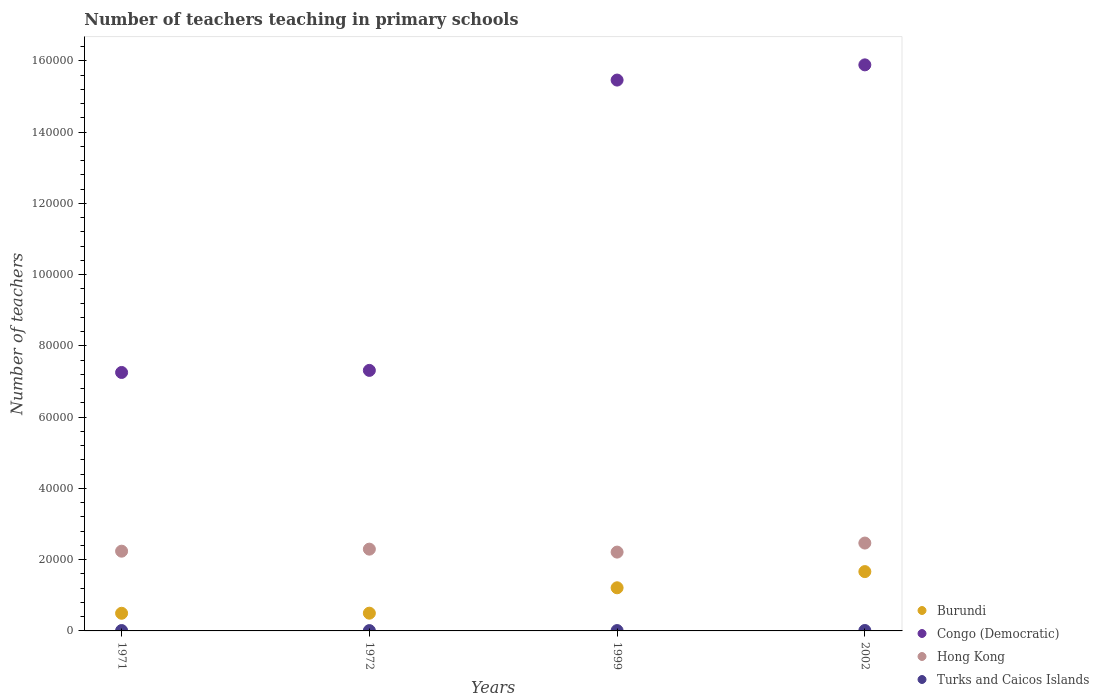What is the number of teachers teaching in primary schools in Hong Kong in 1999?
Your response must be concise. 2.21e+04. Across all years, what is the maximum number of teachers teaching in primary schools in Hong Kong?
Offer a terse response. 2.47e+04. Across all years, what is the minimum number of teachers teaching in primary schools in Turks and Caicos Islands?
Your answer should be very brief. 90. In which year was the number of teachers teaching in primary schools in Congo (Democratic) maximum?
Your answer should be compact. 2002. What is the total number of teachers teaching in primary schools in Congo (Democratic) in the graph?
Your answer should be compact. 4.59e+05. What is the difference between the number of teachers teaching in primary schools in Congo (Democratic) in 1971 and that in 1999?
Your answer should be compact. -8.21e+04. What is the difference between the number of teachers teaching in primary schools in Burundi in 1971 and the number of teachers teaching in primary schools in Turks and Caicos Islands in 1999?
Your answer should be compact. 4856. What is the average number of teachers teaching in primary schools in Hong Kong per year?
Your answer should be very brief. 2.30e+04. In the year 1999, what is the difference between the number of teachers teaching in primary schools in Congo (Democratic) and number of teachers teaching in primary schools in Burundi?
Offer a terse response. 1.43e+05. What is the ratio of the number of teachers teaching in primary schools in Burundi in 1971 to that in 2002?
Offer a very short reply. 0.3. Is the difference between the number of teachers teaching in primary schools in Congo (Democratic) in 1971 and 1972 greater than the difference between the number of teachers teaching in primary schools in Burundi in 1971 and 1972?
Make the answer very short. No. What is the difference between the highest and the second highest number of teachers teaching in primary schools in Congo (Democratic)?
Your answer should be compact. 4269. What is the difference between the highest and the lowest number of teachers teaching in primary schools in Hong Kong?
Your response must be concise. 2540. In how many years, is the number of teachers teaching in primary schools in Burundi greater than the average number of teachers teaching in primary schools in Burundi taken over all years?
Ensure brevity in your answer.  2. Is it the case that in every year, the sum of the number of teachers teaching in primary schools in Burundi and number of teachers teaching in primary schools in Turks and Caicos Islands  is greater than the sum of number of teachers teaching in primary schools in Hong Kong and number of teachers teaching in primary schools in Congo (Democratic)?
Provide a succinct answer. No. Is it the case that in every year, the sum of the number of teachers teaching in primary schools in Hong Kong and number of teachers teaching in primary schools in Congo (Democratic)  is greater than the number of teachers teaching in primary schools in Burundi?
Make the answer very short. Yes. Is the number of teachers teaching in primary schools in Congo (Democratic) strictly less than the number of teachers teaching in primary schools in Turks and Caicos Islands over the years?
Keep it short and to the point. No. How many years are there in the graph?
Provide a short and direct response. 4. What is the difference between two consecutive major ticks on the Y-axis?
Ensure brevity in your answer.  2.00e+04. Are the values on the major ticks of Y-axis written in scientific E-notation?
Make the answer very short. No. Does the graph contain any zero values?
Make the answer very short. No. What is the title of the graph?
Ensure brevity in your answer.  Number of teachers teaching in primary schools. Does "High income: nonOECD" appear as one of the legend labels in the graph?
Ensure brevity in your answer.  No. What is the label or title of the X-axis?
Your answer should be very brief. Years. What is the label or title of the Y-axis?
Your answer should be very brief. Number of teachers. What is the Number of teachers of Burundi in 1971?
Give a very brief answer. 4955. What is the Number of teachers of Congo (Democratic) in 1971?
Ensure brevity in your answer.  7.25e+04. What is the Number of teachers in Hong Kong in 1971?
Your answer should be compact. 2.24e+04. What is the Number of teachers in Turks and Caicos Islands in 1971?
Keep it short and to the point. 106. What is the Number of teachers of Burundi in 1972?
Your response must be concise. 4980. What is the Number of teachers in Congo (Democratic) in 1972?
Keep it short and to the point. 7.31e+04. What is the Number of teachers of Hong Kong in 1972?
Your answer should be compact. 2.30e+04. What is the Number of teachers of Burundi in 1999?
Ensure brevity in your answer.  1.21e+04. What is the Number of teachers of Congo (Democratic) in 1999?
Your answer should be compact. 1.55e+05. What is the Number of teachers of Hong Kong in 1999?
Give a very brief answer. 2.21e+04. What is the Number of teachers in Turks and Caicos Islands in 1999?
Make the answer very short. 99. What is the Number of teachers of Burundi in 2002?
Offer a very short reply. 1.67e+04. What is the Number of teachers of Congo (Democratic) in 2002?
Ensure brevity in your answer.  1.59e+05. What is the Number of teachers in Hong Kong in 2002?
Your response must be concise. 2.47e+04. What is the Number of teachers in Turks and Caicos Islands in 2002?
Make the answer very short. 119. Across all years, what is the maximum Number of teachers of Burundi?
Ensure brevity in your answer.  1.67e+04. Across all years, what is the maximum Number of teachers of Congo (Democratic)?
Offer a very short reply. 1.59e+05. Across all years, what is the maximum Number of teachers of Hong Kong?
Provide a succinct answer. 2.47e+04. Across all years, what is the maximum Number of teachers of Turks and Caicos Islands?
Your response must be concise. 119. Across all years, what is the minimum Number of teachers of Burundi?
Provide a succinct answer. 4955. Across all years, what is the minimum Number of teachers in Congo (Democratic)?
Offer a terse response. 7.25e+04. Across all years, what is the minimum Number of teachers in Hong Kong?
Offer a terse response. 2.21e+04. What is the total Number of teachers in Burundi in the graph?
Your response must be concise. 3.87e+04. What is the total Number of teachers in Congo (Democratic) in the graph?
Make the answer very short. 4.59e+05. What is the total Number of teachers in Hong Kong in the graph?
Your answer should be very brief. 9.21e+04. What is the total Number of teachers of Turks and Caicos Islands in the graph?
Your answer should be compact. 414. What is the difference between the Number of teachers in Burundi in 1971 and that in 1972?
Your answer should be very brief. -25. What is the difference between the Number of teachers of Congo (Democratic) in 1971 and that in 1972?
Your answer should be very brief. -583. What is the difference between the Number of teachers of Hong Kong in 1971 and that in 1972?
Your answer should be very brief. -570. What is the difference between the Number of teachers of Turks and Caicos Islands in 1971 and that in 1972?
Ensure brevity in your answer.  16. What is the difference between the Number of teachers in Burundi in 1971 and that in 1999?
Keep it short and to the point. -7152. What is the difference between the Number of teachers in Congo (Democratic) in 1971 and that in 1999?
Your response must be concise. -8.21e+04. What is the difference between the Number of teachers in Hong Kong in 1971 and that in 1999?
Give a very brief answer. 260. What is the difference between the Number of teachers of Turks and Caicos Islands in 1971 and that in 1999?
Offer a very short reply. 7. What is the difference between the Number of teachers of Burundi in 1971 and that in 2002?
Your answer should be compact. -1.17e+04. What is the difference between the Number of teachers of Congo (Democratic) in 1971 and that in 2002?
Your answer should be very brief. -8.63e+04. What is the difference between the Number of teachers of Hong Kong in 1971 and that in 2002?
Offer a terse response. -2280. What is the difference between the Number of teachers of Turks and Caicos Islands in 1971 and that in 2002?
Provide a succinct answer. -13. What is the difference between the Number of teachers in Burundi in 1972 and that in 1999?
Ensure brevity in your answer.  -7127. What is the difference between the Number of teachers of Congo (Democratic) in 1972 and that in 1999?
Your answer should be compact. -8.15e+04. What is the difference between the Number of teachers in Hong Kong in 1972 and that in 1999?
Make the answer very short. 830. What is the difference between the Number of teachers in Burundi in 1972 and that in 2002?
Give a very brief answer. -1.17e+04. What is the difference between the Number of teachers of Congo (Democratic) in 1972 and that in 2002?
Ensure brevity in your answer.  -8.58e+04. What is the difference between the Number of teachers in Hong Kong in 1972 and that in 2002?
Offer a very short reply. -1710. What is the difference between the Number of teachers in Burundi in 1999 and that in 2002?
Your answer should be very brief. -4544. What is the difference between the Number of teachers of Congo (Democratic) in 1999 and that in 2002?
Provide a short and direct response. -4269. What is the difference between the Number of teachers of Hong Kong in 1999 and that in 2002?
Make the answer very short. -2540. What is the difference between the Number of teachers in Turks and Caicos Islands in 1999 and that in 2002?
Make the answer very short. -20. What is the difference between the Number of teachers in Burundi in 1971 and the Number of teachers in Congo (Democratic) in 1972?
Offer a terse response. -6.82e+04. What is the difference between the Number of teachers in Burundi in 1971 and the Number of teachers in Hong Kong in 1972?
Offer a terse response. -1.80e+04. What is the difference between the Number of teachers in Burundi in 1971 and the Number of teachers in Turks and Caicos Islands in 1972?
Provide a short and direct response. 4865. What is the difference between the Number of teachers of Congo (Democratic) in 1971 and the Number of teachers of Hong Kong in 1972?
Offer a terse response. 4.96e+04. What is the difference between the Number of teachers of Congo (Democratic) in 1971 and the Number of teachers of Turks and Caicos Islands in 1972?
Keep it short and to the point. 7.25e+04. What is the difference between the Number of teachers in Hong Kong in 1971 and the Number of teachers in Turks and Caicos Islands in 1972?
Ensure brevity in your answer.  2.23e+04. What is the difference between the Number of teachers in Burundi in 1971 and the Number of teachers in Congo (Democratic) in 1999?
Keep it short and to the point. -1.50e+05. What is the difference between the Number of teachers of Burundi in 1971 and the Number of teachers of Hong Kong in 1999?
Your answer should be compact. -1.72e+04. What is the difference between the Number of teachers of Burundi in 1971 and the Number of teachers of Turks and Caicos Islands in 1999?
Your answer should be very brief. 4856. What is the difference between the Number of teachers of Congo (Democratic) in 1971 and the Number of teachers of Hong Kong in 1999?
Ensure brevity in your answer.  5.04e+04. What is the difference between the Number of teachers in Congo (Democratic) in 1971 and the Number of teachers in Turks and Caicos Islands in 1999?
Keep it short and to the point. 7.24e+04. What is the difference between the Number of teachers in Hong Kong in 1971 and the Number of teachers in Turks and Caicos Islands in 1999?
Your response must be concise. 2.23e+04. What is the difference between the Number of teachers of Burundi in 1971 and the Number of teachers of Congo (Democratic) in 2002?
Keep it short and to the point. -1.54e+05. What is the difference between the Number of teachers of Burundi in 1971 and the Number of teachers of Hong Kong in 2002?
Your answer should be compact. -1.97e+04. What is the difference between the Number of teachers in Burundi in 1971 and the Number of teachers in Turks and Caicos Islands in 2002?
Your answer should be very brief. 4836. What is the difference between the Number of teachers in Congo (Democratic) in 1971 and the Number of teachers in Hong Kong in 2002?
Give a very brief answer. 4.79e+04. What is the difference between the Number of teachers of Congo (Democratic) in 1971 and the Number of teachers of Turks and Caicos Islands in 2002?
Give a very brief answer. 7.24e+04. What is the difference between the Number of teachers in Hong Kong in 1971 and the Number of teachers in Turks and Caicos Islands in 2002?
Make the answer very short. 2.23e+04. What is the difference between the Number of teachers of Burundi in 1972 and the Number of teachers of Congo (Democratic) in 1999?
Give a very brief answer. -1.50e+05. What is the difference between the Number of teachers of Burundi in 1972 and the Number of teachers of Hong Kong in 1999?
Give a very brief answer. -1.71e+04. What is the difference between the Number of teachers of Burundi in 1972 and the Number of teachers of Turks and Caicos Islands in 1999?
Make the answer very short. 4881. What is the difference between the Number of teachers in Congo (Democratic) in 1972 and the Number of teachers in Hong Kong in 1999?
Keep it short and to the point. 5.10e+04. What is the difference between the Number of teachers of Congo (Democratic) in 1972 and the Number of teachers of Turks and Caicos Islands in 1999?
Provide a short and direct response. 7.30e+04. What is the difference between the Number of teachers of Hong Kong in 1972 and the Number of teachers of Turks and Caicos Islands in 1999?
Provide a short and direct response. 2.29e+04. What is the difference between the Number of teachers in Burundi in 1972 and the Number of teachers in Congo (Democratic) in 2002?
Keep it short and to the point. -1.54e+05. What is the difference between the Number of teachers in Burundi in 1972 and the Number of teachers in Hong Kong in 2002?
Provide a succinct answer. -1.97e+04. What is the difference between the Number of teachers in Burundi in 1972 and the Number of teachers in Turks and Caicos Islands in 2002?
Your answer should be very brief. 4861. What is the difference between the Number of teachers in Congo (Democratic) in 1972 and the Number of teachers in Hong Kong in 2002?
Keep it short and to the point. 4.85e+04. What is the difference between the Number of teachers in Congo (Democratic) in 1972 and the Number of teachers in Turks and Caicos Islands in 2002?
Your response must be concise. 7.30e+04. What is the difference between the Number of teachers in Hong Kong in 1972 and the Number of teachers in Turks and Caicos Islands in 2002?
Make the answer very short. 2.28e+04. What is the difference between the Number of teachers in Burundi in 1999 and the Number of teachers in Congo (Democratic) in 2002?
Your response must be concise. -1.47e+05. What is the difference between the Number of teachers of Burundi in 1999 and the Number of teachers of Hong Kong in 2002?
Make the answer very short. -1.26e+04. What is the difference between the Number of teachers of Burundi in 1999 and the Number of teachers of Turks and Caicos Islands in 2002?
Offer a very short reply. 1.20e+04. What is the difference between the Number of teachers in Congo (Democratic) in 1999 and the Number of teachers in Hong Kong in 2002?
Offer a very short reply. 1.30e+05. What is the difference between the Number of teachers of Congo (Democratic) in 1999 and the Number of teachers of Turks and Caicos Islands in 2002?
Ensure brevity in your answer.  1.54e+05. What is the difference between the Number of teachers of Hong Kong in 1999 and the Number of teachers of Turks and Caicos Islands in 2002?
Your answer should be very brief. 2.20e+04. What is the average Number of teachers of Burundi per year?
Make the answer very short. 9673.25. What is the average Number of teachers of Congo (Democratic) per year?
Provide a succinct answer. 1.15e+05. What is the average Number of teachers in Hong Kong per year?
Offer a terse response. 2.30e+04. What is the average Number of teachers of Turks and Caicos Islands per year?
Your answer should be compact. 103.5. In the year 1971, what is the difference between the Number of teachers in Burundi and Number of teachers in Congo (Democratic)?
Your answer should be compact. -6.76e+04. In the year 1971, what is the difference between the Number of teachers in Burundi and Number of teachers in Hong Kong?
Offer a very short reply. -1.74e+04. In the year 1971, what is the difference between the Number of teachers of Burundi and Number of teachers of Turks and Caicos Islands?
Make the answer very short. 4849. In the year 1971, what is the difference between the Number of teachers of Congo (Democratic) and Number of teachers of Hong Kong?
Your answer should be very brief. 5.02e+04. In the year 1971, what is the difference between the Number of teachers in Congo (Democratic) and Number of teachers in Turks and Caicos Islands?
Your response must be concise. 7.24e+04. In the year 1971, what is the difference between the Number of teachers of Hong Kong and Number of teachers of Turks and Caicos Islands?
Keep it short and to the point. 2.23e+04. In the year 1972, what is the difference between the Number of teachers in Burundi and Number of teachers in Congo (Democratic)?
Keep it short and to the point. -6.81e+04. In the year 1972, what is the difference between the Number of teachers of Burundi and Number of teachers of Hong Kong?
Provide a short and direct response. -1.80e+04. In the year 1972, what is the difference between the Number of teachers in Burundi and Number of teachers in Turks and Caicos Islands?
Keep it short and to the point. 4890. In the year 1972, what is the difference between the Number of teachers in Congo (Democratic) and Number of teachers in Hong Kong?
Ensure brevity in your answer.  5.02e+04. In the year 1972, what is the difference between the Number of teachers of Congo (Democratic) and Number of teachers of Turks and Caicos Islands?
Give a very brief answer. 7.30e+04. In the year 1972, what is the difference between the Number of teachers in Hong Kong and Number of teachers in Turks and Caicos Islands?
Provide a succinct answer. 2.29e+04. In the year 1999, what is the difference between the Number of teachers of Burundi and Number of teachers of Congo (Democratic)?
Offer a very short reply. -1.43e+05. In the year 1999, what is the difference between the Number of teachers of Burundi and Number of teachers of Hong Kong?
Keep it short and to the point. -1.00e+04. In the year 1999, what is the difference between the Number of teachers in Burundi and Number of teachers in Turks and Caicos Islands?
Offer a terse response. 1.20e+04. In the year 1999, what is the difference between the Number of teachers in Congo (Democratic) and Number of teachers in Hong Kong?
Keep it short and to the point. 1.32e+05. In the year 1999, what is the difference between the Number of teachers in Congo (Democratic) and Number of teachers in Turks and Caicos Islands?
Offer a terse response. 1.55e+05. In the year 1999, what is the difference between the Number of teachers of Hong Kong and Number of teachers of Turks and Caicos Islands?
Provide a succinct answer. 2.20e+04. In the year 2002, what is the difference between the Number of teachers of Burundi and Number of teachers of Congo (Democratic)?
Ensure brevity in your answer.  -1.42e+05. In the year 2002, what is the difference between the Number of teachers in Burundi and Number of teachers in Hong Kong?
Offer a terse response. -8012. In the year 2002, what is the difference between the Number of teachers of Burundi and Number of teachers of Turks and Caicos Islands?
Ensure brevity in your answer.  1.65e+04. In the year 2002, what is the difference between the Number of teachers in Congo (Democratic) and Number of teachers in Hong Kong?
Offer a terse response. 1.34e+05. In the year 2002, what is the difference between the Number of teachers of Congo (Democratic) and Number of teachers of Turks and Caicos Islands?
Your answer should be compact. 1.59e+05. In the year 2002, what is the difference between the Number of teachers in Hong Kong and Number of teachers in Turks and Caicos Islands?
Ensure brevity in your answer.  2.45e+04. What is the ratio of the Number of teachers of Hong Kong in 1971 to that in 1972?
Your response must be concise. 0.98. What is the ratio of the Number of teachers of Turks and Caicos Islands in 1971 to that in 1972?
Keep it short and to the point. 1.18. What is the ratio of the Number of teachers in Burundi in 1971 to that in 1999?
Provide a short and direct response. 0.41. What is the ratio of the Number of teachers of Congo (Democratic) in 1971 to that in 1999?
Provide a succinct answer. 0.47. What is the ratio of the Number of teachers in Hong Kong in 1971 to that in 1999?
Give a very brief answer. 1.01. What is the ratio of the Number of teachers of Turks and Caicos Islands in 1971 to that in 1999?
Give a very brief answer. 1.07. What is the ratio of the Number of teachers of Burundi in 1971 to that in 2002?
Keep it short and to the point. 0.3. What is the ratio of the Number of teachers in Congo (Democratic) in 1971 to that in 2002?
Your answer should be compact. 0.46. What is the ratio of the Number of teachers of Hong Kong in 1971 to that in 2002?
Your answer should be very brief. 0.91. What is the ratio of the Number of teachers in Turks and Caicos Islands in 1971 to that in 2002?
Your response must be concise. 0.89. What is the ratio of the Number of teachers in Burundi in 1972 to that in 1999?
Keep it short and to the point. 0.41. What is the ratio of the Number of teachers of Congo (Democratic) in 1972 to that in 1999?
Your answer should be very brief. 0.47. What is the ratio of the Number of teachers in Hong Kong in 1972 to that in 1999?
Provide a succinct answer. 1.04. What is the ratio of the Number of teachers of Burundi in 1972 to that in 2002?
Give a very brief answer. 0.3. What is the ratio of the Number of teachers of Congo (Democratic) in 1972 to that in 2002?
Your answer should be compact. 0.46. What is the ratio of the Number of teachers in Hong Kong in 1972 to that in 2002?
Give a very brief answer. 0.93. What is the ratio of the Number of teachers of Turks and Caicos Islands in 1972 to that in 2002?
Give a very brief answer. 0.76. What is the ratio of the Number of teachers of Burundi in 1999 to that in 2002?
Ensure brevity in your answer.  0.73. What is the ratio of the Number of teachers in Congo (Democratic) in 1999 to that in 2002?
Your answer should be compact. 0.97. What is the ratio of the Number of teachers of Hong Kong in 1999 to that in 2002?
Your answer should be compact. 0.9. What is the ratio of the Number of teachers of Turks and Caicos Islands in 1999 to that in 2002?
Offer a very short reply. 0.83. What is the difference between the highest and the second highest Number of teachers of Burundi?
Your answer should be compact. 4544. What is the difference between the highest and the second highest Number of teachers in Congo (Democratic)?
Give a very brief answer. 4269. What is the difference between the highest and the second highest Number of teachers of Hong Kong?
Provide a short and direct response. 1710. What is the difference between the highest and the second highest Number of teachers in Turks and Caicos Islands?
Give a very brief answer. 13. What is the difference between the highest and the lowest Number of teachers in Burundi?
Your answer should be compact. 1.17e+04. What is the difference between the highest and the lowest Number of teachers in Congo (Democratic)?
Ensure brevity in your answer.  8.63e+04. What is the difference between the highest and the lowest Number of teachers in Hong Kong?
Your response must be concise. 2540. What is the difference between the highest and the lowest Number of teachers in Turks and Caicos Islands?
Offer a terse response. 29. 